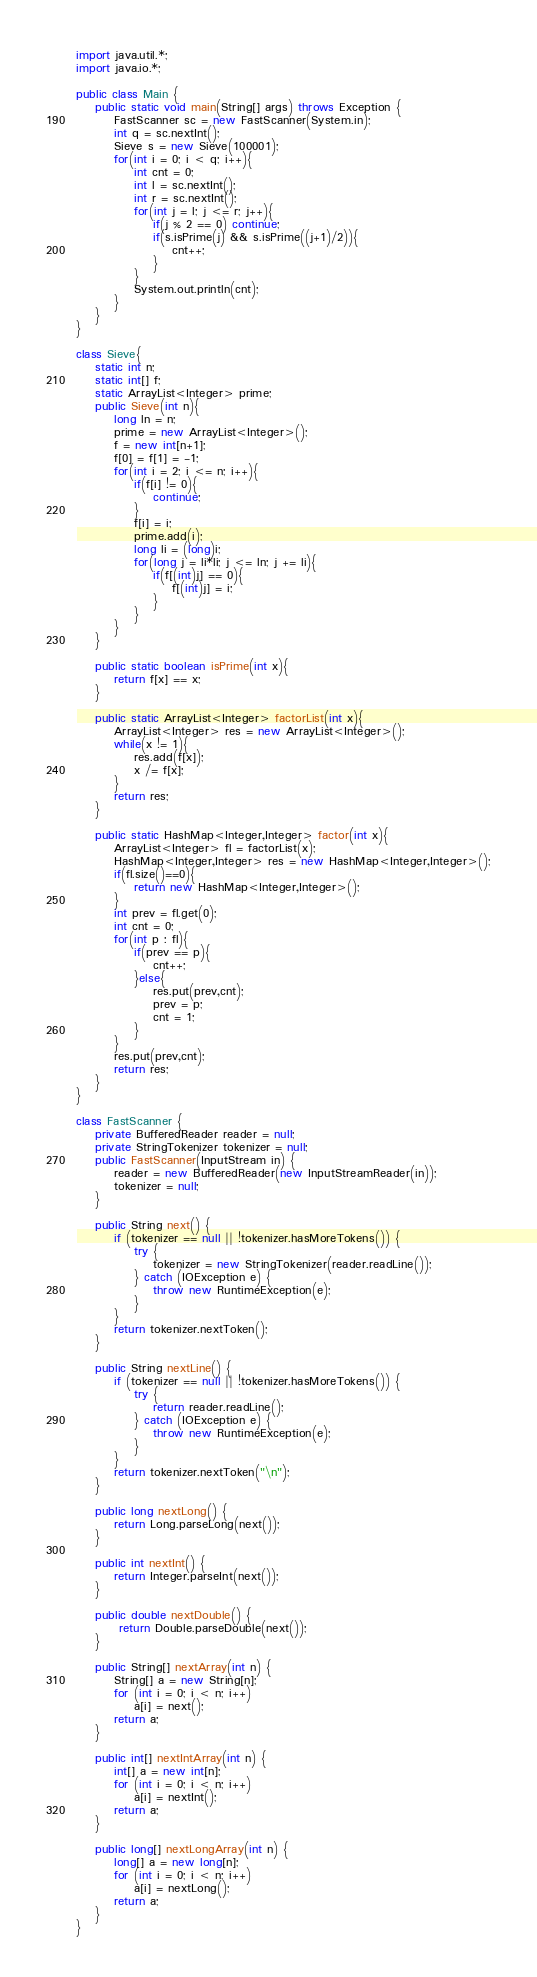Convert code to text. <code><loc_0><loc_0><loc_500><loc_500><_Java_>import java.util.*;
import java.io.*;
 
public class Main {
    public static void main(String[] args) throws Exception {
        FastScanner sc = new FastScanner(System.in);
        int q = sc.nextInt();
        Sieve s = new Sieve(100001);
        for(int i = 0; i < q; i++){
            int cnt = 0;
            int l = sc.nextInt();
            int r = sc.nextInt();
            for(int j = l; j <= r; j++){
                if(j % 2 == 0) continue;
                if(s.isPrime(j) && s.isPrime((j+1)/2)){
                    cnt++;
                }
            }
            System.out.println(cnt);
        }
    }
}

class Sieve{
    static int n;
    static int[] f;
    static ArrayList<Integer> prime;
    public Sieve(int n){
        long ln = n;
        prime = new ArrayList<Integer>();
        f = new int[n+1];
        f[0] = f[1] = -1;
        for(int i = 2; i <= n; i++){
            if(f[i] != 0){
                continue;
            }
            f[i] = i;
            prime.add(i);
            long li = (long)i;
            for(long j = li*li; j <= ln; j += li){
                if(f[(int)j] == 0){
                    f[(int)j] = i;
                }
            }
        }
    }
    
    public static boolean isPrime(int x){
        return f[x] == x;
    }
    
    public static ArrayList<Integer> factorList(int x){
        ArrayList<Integer> res = new ArrayList<Integer>();
        while(x != 1){
            res.add(f[x]);
            x /= f[x];
        }
        return res;
    }
    
    public static HashMap<Integer,Integer> factor(int x){
        ArrayList<Integer> fl = factorList(x);
        HashMap<Integer,Integer> res = new HashMap<Integer,Integer>();
        if(fl.size()==0){
            return new HashMap<Integer,Integer>();
        }
        int prev = fl.get(0);
        int cnt = 0;
        for(int p : fl){
            if(prev == p){
                cnt++;
            }else{
                res.put(prev,cnt);
                prev = p;
                cnt = 1;
            }
        }
        res.put(prev,cnt);
        return res;
    }
}

class FastScanner {
    private BufferedReader reader = null;
    private StringTokenizer tokenizer = null;
    public FastScanner(InputStream in) {
        reader = new BufferedReader(new InputStreamReader(in));
        tokenizer = null;
    }

    public String next() {
        if (tokenizer == null || !tokenizer.hasMoreTokens()) {
            try {
                tokenizer = new StringTokenizer(reader.readLine());
            } catch (IOException e) {
                throw new RuntimeException(e);
            }
        }
        return tokenizer.nextToken();
    }

    public String nextLine() {
        if (tokenizer == null || !tokenizer.hasMoreTokens()) {
            try {
                return reader.readLine();
            } catch (IOException e) {
                throw new RuntimeException(e);
            }
        }
        return tokenizer.nextToken("\n");
    }

    public long nextLong() {
        return Long.parseLong(next());
    }

    public int nextInt() {
        return Integer.parseInt(next());
    }

    public double nextDouble() {
         return Double.parseDouble(next());
    }
    
    public String[] nextArray(int n) {
        String[] a = new String[n];
        for (int i = 0; i < n; i++)
            a[i] = next();
        return a;
    }

    public int[] nextIntArray(int n) {
        int[] a = new int[n];
        for (int i = 0; i < n; i++)
            a[i] = nextInt();
        return a;
    }

    public long[] nextLongArray(int n) {
        long[] a = new long[n];
        for (int i = 0; i < n; i++)
            a[i] = nextLong();
        return a;
    } 
}
</code> 